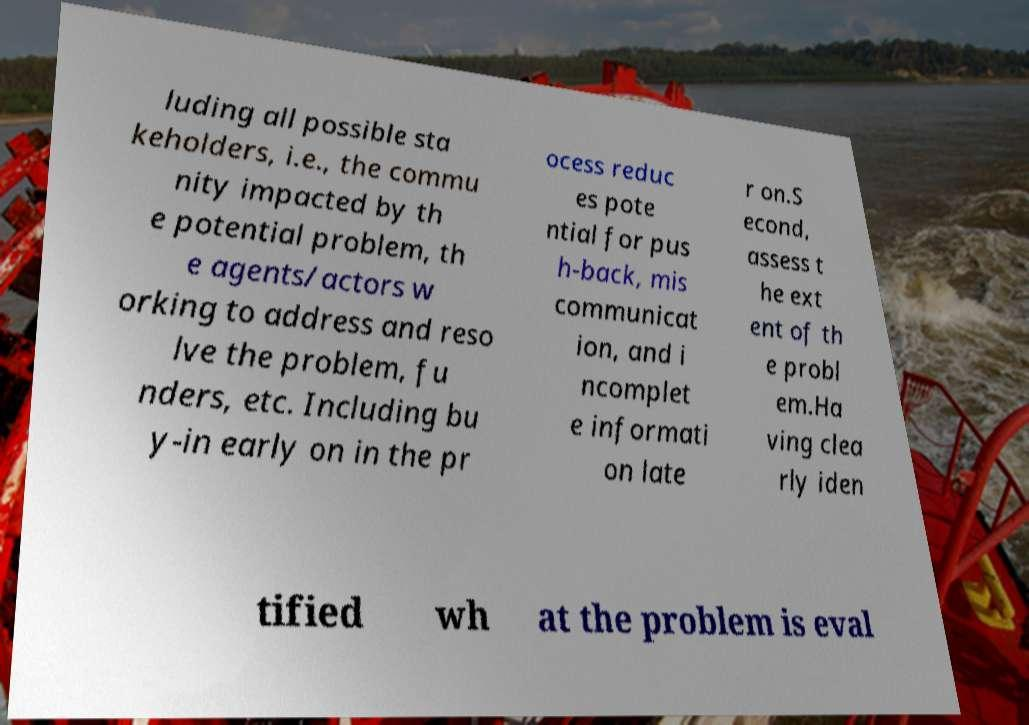I need the written content from this picture converted into text. Can you do that? luding all possible sta keholders, i.e., the commu nity impacted by th e potential problem, th e agents/actors w orking to address and reso lve the problem, fu nders, etc. Including bu y-in early on in the pr ocess reduc es pote ntial for pus h-back, mis communicat ion, and i ncomplet e informati on late r on.S econd, assess t he ext ent of th e probl em.Ha ving clea rly iden tified wh at the problem is eval 